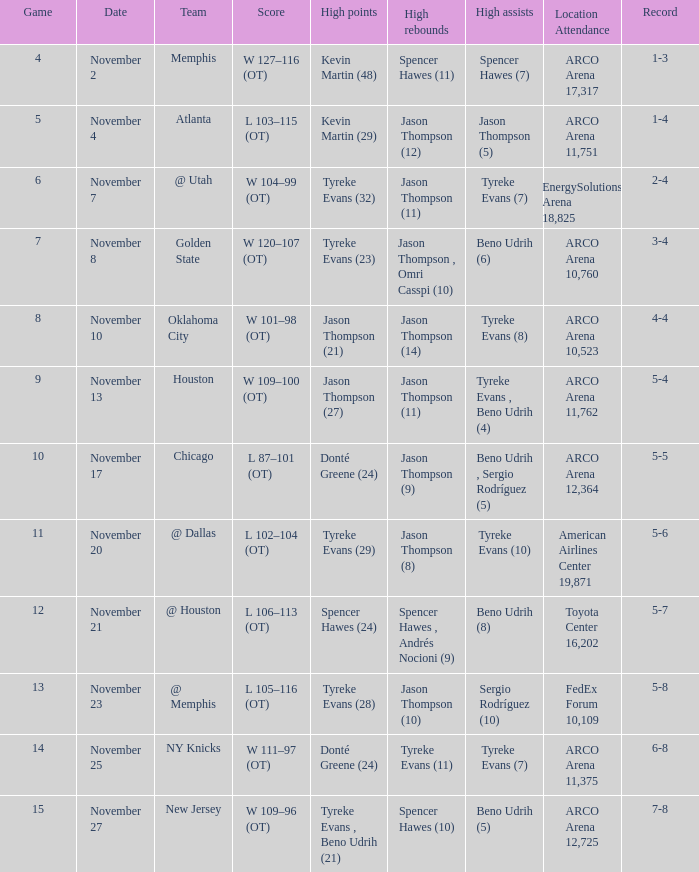If the tally is 5-8, what is the name of the team? @ Memphis. 